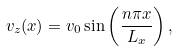<formula> <loc_0><loc_0><loc_500><loc_500>v _ { z } ( x ) = v _ { 0 } \sin \left ( \frac { n \pi x } { L _ { x } } \right ) ,</formula> 